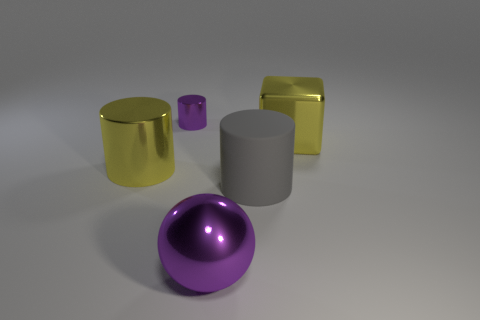Add 3 large gray shiny objects. How many objects exist? 8 Subtract all spheres. How many objects are left? 4 Subtract 1 purple spheres. How many objects are left? 4 Subtract all purple metallic objects. Subtract all large cylinders. How many objects are left? 1 Add 3 metallic cylinders. How many metallic cylinders are left? 5 Add 2 large yellow matte blocks. How many large yellow matte blocks exist? 2 